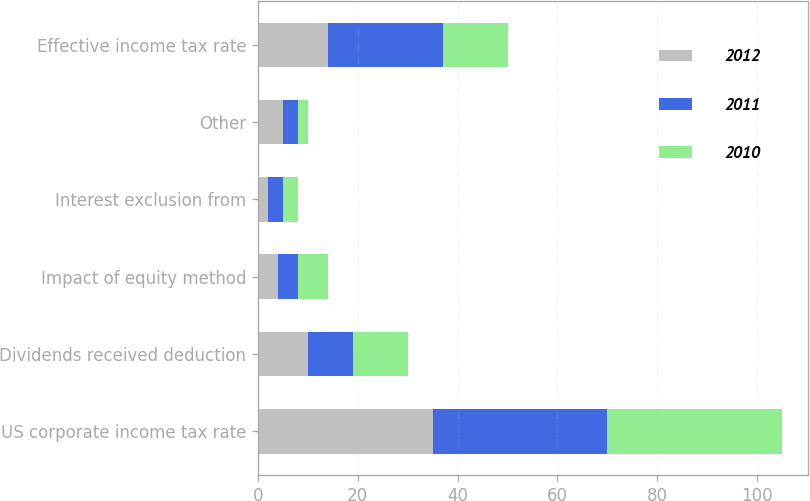Convert chart to OTSL. <chart><loc_0><loc_0><loc_500><loc_500><stacked_bar_chart><ecel><fcel>US corporate income tax rate<fcel>Dividends received deduction<fcel>Impact of equity method<fcel>Interest exclusion from<fcel>Other<fcel>Effective income tax rate<nl><fcel>2012<fcel>35<fcel>10<fcel>4<fcel>2<fcel>5<fcel>14<nl><fcel>2011<fcel>35<fcel>9<fcel>4<fcel>3<fcel>3<fcel>23<nl><fcel>2010<fcel>35<fcel>11<fcel>6<fcel>3<fcel>2<fcel>13<nl></chart> 